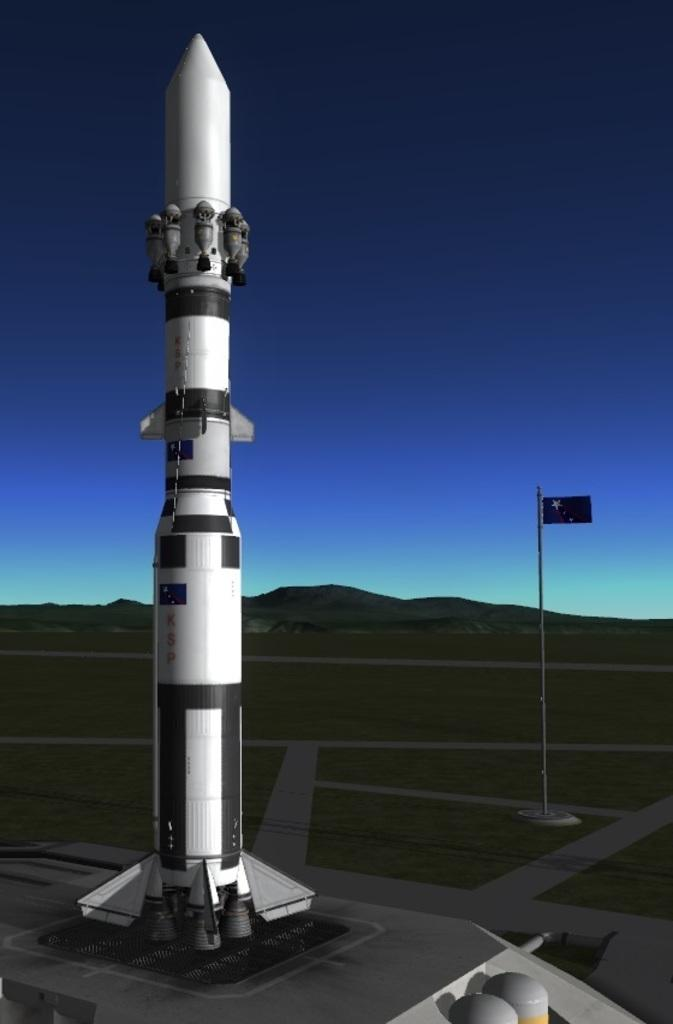What is the main subject of the image? The main subject of the image is a rocket. What can be seen on the right side of the image? There is a flag on the right side of the image. What is visible at the top of the image? The sky is visible at the top of the image. How many ducks are swimming in the rocket in the image? There are no ducks present in the image, and the rocket is not a body of water where ducks would swim. 